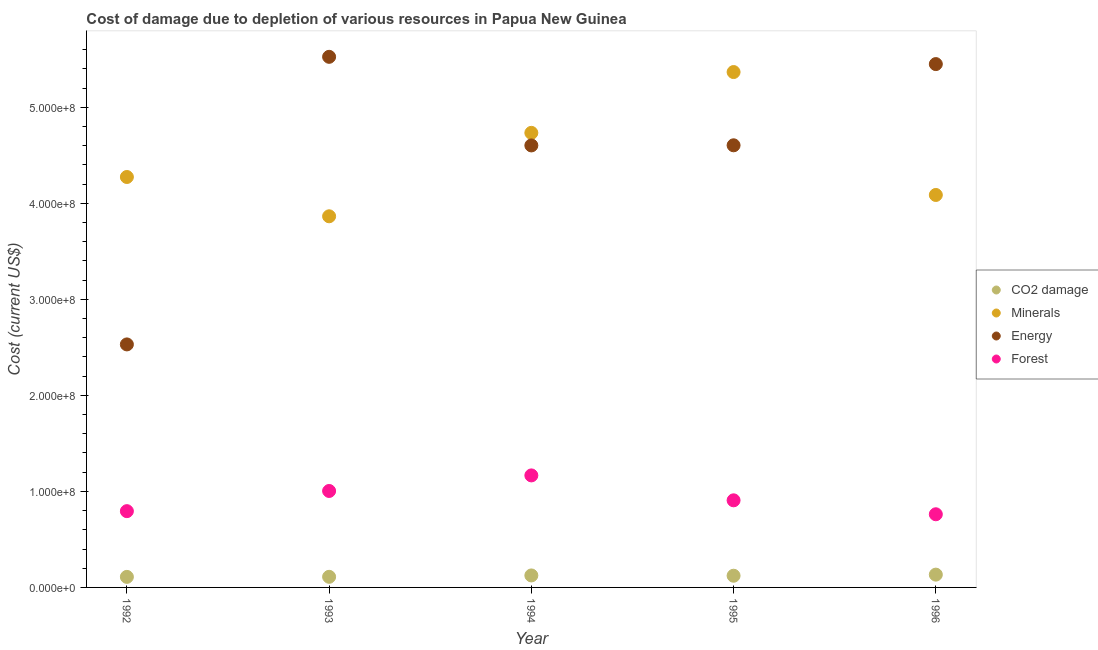What is the cost of damage due to depletion of coal in 1996?
Your response must be concise. 1.33e+07. Across all years, what is the maximum cost of damage due to depletion of energy?
Your response must be concise. 5.53e+08. Across all years, what is the minimum cost of damage due to depletion of minerals?
Offer a very short reply. 3.86e+08. What is the total cost of damage due to depletion of coal in the graph?
Your response must be concise. 6.00e+07. What is the difference between the cost of damage due to depletion of energy in 1995 and that in 1996?
Make the answer very short. -8.46e+07. What is the difference between the cost of damage due to depletion of energy in 1994 and the cost of damage due to depletion of forests in 1995?
Offer a terse response. 3.70e+08. What is the average cost of damage due to depletion of energy per year?
Your response must be concise. 4.54e+08. In the year 1992, what is the difference between the cost of damage due to depletion of energy and cost of damage due to depletion of minerals?
Your response must be concise. -1.74e+08. In how many years, is the cost of damage due to depletion of coal greater than 520000000 US$?
Make the answer very short. 0. What is the ratio of the cost of damage due to depletion of forests in 1992 to that in 1996?
Offer a terse response. 1.04. Is the difference between the cost of damage due to depletion of coal in 1993 and 1995 greater than the difference between the cost of damage due to depletion of minerals in 1993 and 1995?
Offer a terse response. Yes. What is the difference between the highest and the second highest cost of damage due to depletion of forests?
Give a very brief answer. 1.62e+07. What is the difference between the highest and the lowest cost of damage due to depletion of minerals?
Keep it short and to the point. 1.50e+08. In how many years, is the cost of damage due to depletion of energy greater than the average cost of damage due to depletion of energy taken over all years?
Keep it short and to the point. 4. Is it the case that in every year, the sum of the cost of damage due to depletion of forests and cost of damage due to depletion of minerals is greater than the sum of cost of damage due to depletion of coal and cost of damage due to depletion of energy?
Your response must be concise. No. Does the cost of damage due to depletion of energy monotonically increase over the years?
Provide a short and direct response. No. How many dotlines are there?
Provide a succinct answer. 4. What is the difference between two consecutive major ticks on the Y-axis?
Ensure brevity in your answer.  1.00e+08. Are the values on the major ticks of Y-axis written in scientific E-notation?
Make the answer very short. Yes. Does the graph contain grids?
Keep it short and to the point. No. Where does the legend appear in the graph?
Provide a short and direct response. Center right. How many legend labels are there?
Offer a terse response. 4. How are the legend labels stacked?
Provide a short and direct response. Vertical. What is the title of the graph?
Offer a terse response. Cost of damage due to depletion of various resources in Papua New Guinea . What is the label or title of the X-axis?
Your answer should be very brief. Year. What is the label or title of the Y-axis?
Ensure brevity in your answer.  Cost (current US$). What is the Cost (current US$) of CO2 damage in 1992?
Your answer should be compact. 1.10e+07. What is the Cost (current US$) of Minerals in 1992?
Offer a terse response. 4.27e+08. What is the Cost (current US$) in Energy in 1992?
Offer a very short reply. 2.53e+08. What is the Cost (current US$) in Forest in 1992?
Give a very brief answer. 7.94e+07. What is the Cost (current US$) in CO2 damage in 1993?
Offer a terse response. 1.10e+07. What is the Cost (current US$) in Minerals in 1993?
Offer a terse response. 3.86e+08. What is the Cost (current US$) in Energy in 1993?
Offer a terse response. 5.53e+08. What is the Cost (current US$) of Forest in 1993?
Keep it short and to the point. 1.00e+08. What is the Cost (current US$) of CO2 damage in 1994?
Offer a very short reply. 1.25e+07. What is the Cost (current US$) in Minerals in 1994?
Your answer should be compact. 4.73e+08. What is the Cost (current US$) in Energy in 1994?
Ensure brevity in your answer.  4.60e+08. What is the Cost (current US$) of Forest in 1994?
Make the answer very short. 1.17e+08. What is the Cost (current US$) of CO2 damage in 1995?
Ensure brevity in your answer.  1.22e+07. What is the Cost (current US$) of Minerals in 1995?
Give a very brief answer. 5.37e+08. What is the Cost (current US$) of Energy in 1995?
Provide a short and direct response. 4.60e+08. What is the Cost (current US$) of Forest in 1995?
Provide a short and direct response. 9.07e+07. What is the Cost (current US$) in CO2 damage in 1996?
Keep it short and to the point. 1.33e+07. What is the Cost (current US$) of Minerals in 1996?
Offer a terse response. 4.09e+08. What is the Cost (current US$) in Energy in 1996?
Make the answer very short. 5.45e+08. What is the Cost (current US$) of Forest in 1996?
Provide a succinct answer. 7.62e+07. Across all years, what is the maximum Cost (current US$) in CO2 damage?
Your answer should be very brief. 1.33e+07. Across all years, what is the maximum Cost (current US$) of Minerals?
Your answer should be very brief. 5.37e+08. Across all years, what is the maximum Cost (current US$) in Energy?
Your answer should be very brief. 5.53e+08. Across all years, what is the maximum Cost (current US$) of Forest?
Your response must be concise. 1.17e+08. Across all years, what is the minimum Cost (current US$) in CO2 damage?
Your answer should be very brief. 1.10e+07. Across all years, what is the minimum Cost (current US$) of Minerals?
Your answer should be compact. 3.86e+08. Across all years, what is the minimum Cost (current US$) of Energy?
Provide a succinct answer. 2.53e+08. Across all years, what is the minimum Cost (current US$) in Forest?
Give a very brief answer. 7.62e+07. What is the total Cost (current US$) in CO2 damage in the graph?
Offer a very short reply. 6.00e+07. What is the total Cost (current US$) of Minerals in the graph?
Your answer should be compact. 2.23e+09. What is the total Cost (current US$) of Energy in the graph?
Provide a short and direct response. 2.27e+09. What is the total Cost (current US$) of Forest in the graph?
Provide a short and direct response. 4.63e+08. What is the difference between the Cost (current US$) of CO2 damage in 1992 and that in 1993?
Your answer should be compact. -6.84e+04. What is the difference between the Cost (current US$) of Minerals in 1992 and that in 1993?
Ensure brevity in your answer.  4.09e+07. What is the difference between the Cost (current US$) in Energy in 1992 and that in 1993?
Keep it short and to the point. -2.99e+08. What is the difference between the Cost (current US$) in Forest in 1992 and that in 1993?
Give a very brief answer. -2.10e+07. What is the difference between the Cost (current US$) in CO2 damage in 1992 and that in 1994?
Your answer should be compact. -1.51e+06. What is the difference between the Cost (current US$) in Minerals in 1992 and that in 1994?
Offer a very short reply. -4.60e+07. What is the difference between the Cost (current US$) in Energy in 1992 and that in 1994?
Ensure brevity in your answer.  -2.07e+08. What is the difference between the Cost (current US$) of Forest in 1992 and that in 1994?
Your answer should be very brief. -3.72e+07. What is the difference between the Cost (current US$) of CO2 damage in 1992 and that in 1995?
Your answer should be very brief. -1.20e+06. What is the difference between the Cost (current US$) in Minerals in 1992 and that in 1995?
Make the answer very short. -1.09e+08. What is the difference between the Cost (current US$) of Energy in 1992 and that in 1995?
Your answer should be compact. -2.07e+08. What is the difference between the Cost (current US$) in Forest in 1992 and that in 1995?
Offer a very short reply. -1.13e+07. What is the difference between the Cost (current US$) of CO2 damage in 1992 and that in 1996?
Provide a succinct answer. -2.35e+06. What is the difference between the Cost (current US$) in Minerals in 1992 and that in 1996?
Provide a succinct answer. 1.87e+07. What is the difference between the Cost (current US$) in Energy in 1992 and that in 1996?
Ensure brevity in your answer.  -2.92e+08. What is the difference between the Cost (current US$) in Forest in 1992 and that in 1996?
Your answer should be compact. 3.24e+06. What is the difference between the Cost (current US$) in CO2 damage in 1993 and that in 1994?
Keep it short and to the point. -1.44e+06. What is the difference between the Cost (current US$) of Minerals in 1993 and that in 1994?
Your answer should be very brief. -8.69e+07. What is the difference between the Cost (current US$) of Energy in 1993 and that in 1994?
Give a very brief answer. 9.23e+07. What is the difference between the Cost (current US$) in Forest in 1993 and that in 1994?
Offer a terse response. -1.62e+07. What is the difference between the Cost (current US$) in CO2 damage in 1993 and that in 1995?
Offer a very short reply. -1.13e+06. What is the difference between the Cost (current US$) in Minerals in 1993 and that in 1995?
Ensure brevity in your answer.  -1.50e+08. What is the difference between the Cost (current US$) in Energy in 1993 and that in 1995?
Make the answer very short. 9.21e+07. What is the difference between the Cost (current US$) in Forest in 1993 and that in 1995?
Keep it short and to the point. 9.73e+06. What is the difference between the Cost (current US$) of CO2 damage in 1993 and that in 1996?
Offer a terse response. -2.28e+06. What is the difference between the Cost (current US$) in Minerals in 1993 and that in 1996?
Offer a terse response. -2.22e+07. What is the difference between the Cost (current US$) in Energy in 1993 and that in 1996?
Your answer should be compact. 7.56e+06. What is the difference between the Cost (current US$) of Forest in 1993 and that in 1996?
Provide a succinct answer. 2.43e+07. What is the difference between the Cost (current US$) in CO2 damage in 1994 and that in 1995?
Your answer should be compact. 3.05e+05. What is the difference between the Cost (current US$) of Minerals in 1994 and that in 1995?
Give a very brief answer. -6.33e+07. What is the difference between the Cost (current US$) in Energy in 1994 and that in 1995?
Offer a terse response. -1.42e+05. What is the difference between the Cost (current US$) of Forest in 1994 and that in 1995?
Offer a terse response. 2.59e+07. What is the difference between the Cost (current US$) in CO2 damage in 1994 and that in 1996?
Your response must be concise. -8.44e+05. What is the difference between the Cost (current US$) of Minerals in 1994 and that in 1996?
Offer a terse response. 6.47e+07. What is the difference between the Cost (current US$) in Energy in 1994 and that in 1996?
Provide a succinct answer. -8.47e+07. What is the difference between the Cost (current US$) of Forest in 1994 and that in 1996?
Offer a terse response. 4.05e+07. What is the difference between the Cost (current US$) in CO2 damage in 1995 and that in 1996?
Your answer should be compact. -1.15e+06. What is the difference between the Cost (current US$) in Minerals in 1995 and that in 1996?
Offer a very short reply. 1.28e+08. What is the difference between the Cost (current US$) in Energy in 1995 and that in 1996?
Your response must be concise. -8.46e+07. What is the difference between the Cost (current US$) of Forest in 1995 and that in 1996?
Make the answer very short. 1.45e+07. What is the difference between the Cost (current US$) in CO2 damage in 1992 and the Cost (current US$) in Minerals in 1993?
Offer a very short reply. -3.75e+08. What is the difference between the Cost (current US$) of CO2 damage in 1992 and the Cost (current US$) of Energy in 1993?
Offer a very short reply. -5.42e+08. What is the difference between the Cost (current US$) of CO2 damage in 1992 and the Cost (current US$) of Forest in 1993?
Provide a succinct answer. -8.95e+07. What is the difference between the Cost (current US$) in Minerals in 1992 and the Cost (current US$) in Energy in 1993?
Your response must be concise. -1.25e+08. What is the difference between the Cost (current US$) of Minerals in 1992 and the Cost (current US$) of Forest in 1993?
Your answer should be very brief. 3.27e+08. What is the difference between the Cost (current US$) in Energy in 1992 and the Cost (current US$) in Forest in 1993?
Ensure brevity in your answer.  1.53e+08. What is the difference between the Cost (current US$) of CO2 damage in 1992 and the Cost (current US$) of Minerals in 1994?
Offer a terse response. -4.62e+08. What is the difference between the Cost (current US$) of CO2 damage in 1992 and the Cost (current US$) of Energy in 1994?
Your answer should be compact. -4.49e+08. What is the difference between the Cost (current US$) in CO2 damage in 1992 and the Cost (current US$) in Forest in 1994?
Ensure brevity in your answer.  -1.06e+08. What is the difference between the Cost (current US$) in Minerals in 1992 and the Cost (current US$) in Energy in 1994?
Keep it short and to the point. -3.29e+07. What is the difference between the Cost (current US$) in Minerals in 1992 and the Cost (current US$) in Forest in 1994?
Provide a short and direct response. 3.11e+08. What is the difference between the Cost (current US$) of Energy in 1992 and the Cost (current US$) of Forest in 1994?
Make the answer very short. 1.36e+08. What is the difference between the Cost (current US$) of CO2 damage in 1992 and the Cost (current US$) of Minerals in 1995?
Make the answer very short. -5.26e+08. What is the difference between the Cost (current US$) in CO2 damage in 1992 and the Cost (current US$) in Energy in 1995?
Offer a terse response. -4.49e+08. What is the difference between the Cost (current US$) of CO2 damage in 1992 and the Cost (current US$) of Forest in 1995?
Your answer should be very brief. -7.97e+07. What is the difference between the Cost (current US$) of Minerals in 1992 and the Cost (current US$) of Energy in 1995?
Your response must be concise. -3.30e+07. What is the difference between the Cost (current US$) of Minerals in 1992 and the Cost (current US$) of Forest in 1995?
Your response must be concise. 3.37e+08. What is the difference between the Cost (current US$) in Energy in 1992 and the Cost (current US$) in Forest in 1995?
Keep it short and to the point. 1.62e+08. What is the difference between the Cost (current US$) of CO2 damage in 1992 and the Cost (current US$) of Minerals in 1996?
Provide a short and direct response. -3.98e+08. What is the difference between the Cost (current US$) of CO2 damage in 1992 and the Cost (current US$) of Energy in 1996?
Ensure brevity in your answer.  -5.34e+08. What is the difference between the Cost (current US$) of CO2 damage in 1992 and the Cost (current US$) of Forest in 1996?
Your response must be concise. -6.52e+07. What is the difference between the Cost (current US$) in Minerals in 1992 and the Cost (current US$) in Energy in 1996?
Your answer should be very brief. -1.18e+08. What is the difference between the Cost (current US$) in Minerals in 1992 and the Cost (current US$) in Forest in 1996?
Offer a terse response. 3.51e+08. What is the difference between the Cost (current US$) of Energy in 1992 and the Cost (current US$) of Forest in 1996?
Provide a short and direct response. 1.77e+08. What is the difference between the Cost (current US$) of CO2 damage in 1993 and the Cost (current US$) of Minerals in 1994?
Ensure brevity in your answer.  -4.62e+08. What is the difference between the Cost (current US$) in CO2 damage in 1993 and the Cost (current US$) in Energy in 1994?
Offer a very short reply. -4.49e+08. What is the difference between the Cost (current US$) in CO2 damage in 1993 and the Cost (current US$) in Forest in 1994?
Offer a very short reply. -1.06e+08. What is the difference between the Cost (current US$) in Minerals in 1993 and the Cost (current US$) in Energy in 1994?
Provide a succinct answer. -7.38e+07. What is the difference between the Cost (current US$) in Minerals in 1993 and the Cost (current US$) in Forest in 1994?
Your answer should be compact. 2.70e+08. What is the difference between the Cost (current US$) in Energy in 1993 and the Cost (current US$) in Forest in 1994?
Your answer should be very brief. 4.36e+08. What is the difference between the Cost (current US$) of CO2 damage in 1993 and the Cost (current US$) of Minerals in 1995?
Offer a very short reply. -5.26e+08. What is the difference between the Cost (current US$) in CO2 damage in 1993 and the Cost (current US$) in Energy in 1995?
Provide a short and direct response. -4.49e+08. What is the difference between the Cost (current US$) in CO2 damage in 1993 and the Cost (current US$) in Forest in 1995?
Keep it short and to the point. -7.97e+07. What is the difference between the Cost (current US$) in Minerals in 1993 and the Cost (current US$) in Energy in 1995?
Offer a very short reply. -7.39e+07. What is the difference between the Cost (current US$) of Minerals in 1993 and the Cost (current US$) of Forest in 1995?
Your answer should be compact. 2.96e+08. What is the difference between the Cost (current US$) in Energy in 1993 and the Cost (current US$) in Forest in 1995?
Ensure brevity in your answer.  4.62e+08. What is the difference between the Cost (current US$) of CO2 damage in 1993 and the Cost (current US$) of Minerals in 1996?
Ensure brevity in your answer.  -3.98e+08. What is the difference between the Cost (current US$) in CO2 damage in 1993 and the Cost (current US$) in Energy in 1996?
Your response must be concise. -5.34e+08. What is the difference between the Cost (current US$) of CO2 damage in 1993 and the Cost (current US$) of Forest in 1996?
Your answer should be very brief. -6.51e+07. What is the difference between the Cost (current US$) of Minerals in 1993 and the Cost (current US$) of Energy in 1996?
Make the answer very short. -1.58e+08. What is the difference between the Cost (current US$) in Minerals in 1993 and the Cost (current US$) in Forest in 1996?
Offer a terse response. 3.10e+08. What is the difference between the Cost (current US$) in Energy in 1993 and the Cost (current US$) in Forest in 1996?
Offer a very short reply. 4.76e+08. What is the difference between the Cost (current US$) of CO2 damage in 1994 and the Cost (current US$) of Minerals in 1995?
Provide a succinct answer. -5.24e+08. What is the difference between the Cost (current US$) in CO2 damage in 1994 and the Cost (current US$) in Energy in 1995?
Your answer should be very brief. -4.48e+08. What is the difference between the Cost (current US$) of CO2 damage in 1994 and the Cost (current US$) of Forest in 1995?
Your answer should be compact. -7.82e+07. What is the difference between the Cost (current US$) in Minerals in 1994 and the Cost (current US$) in Energy in 1995?
Your answer should be compact. 1.30e+07. What is the difference between the Cost (current US$) in Minerals in 1994 and the Cost (current US$) in Forest in 1995?
Keep it short and to the point. 3.83e+08. What is the difference between the Cost (current US$) in Energy in 1994 and the Cost (current US$) in Forest in 1995?
Make the answer very short. 3.70e+08. What is the difference between the Cost (current US$) in CO2 damage in 1994 and the Cost (current US$) in Minerals in 1996?
Offer a terse response. -3.96e+08. What is the difference between the Cost (current US$) in CO2 damage in 1994 and the Cost (current US$) in Energy in 1996?
Provide a short and direct response. -5.32e+08. What is the difference between the Cost (current US$) in CO2 damage in 1994 and the Cost (current US$) in Forest in 1996?
Give a very brief answer. -6.37e+07. What is the difference between the Cost (current US$) of Minerals in 1994 and the Cost (current US$) of Energy in 1996?
Your answer should be very brief. -7.16e+07. What is the difference between the Cost (current US$) in Minerals in 1994 and the Cost (current US$) in Forest in 1996?
Make the answer very short. 3.97e+08. What is the difference between the Cost (current US$) in Energy in 1994 and the Cost (current US$) in Forest in 1996?
Keep it short and to the point. 3.84e+08. What is the difference between the Cost (current US$) in CO2 damage in 1995 and the Cost (current US$) in Minerals in 1996?
Provide a short and direct response. -3.96e+08. What is the difference between the Cost (current US$) in CO2 damage in 1995 and the Cost (current US$) in Energy in 1996?
Offer a very short reply. -5.33e+08. What is the difference between the Cost (current US$) of CO2 damage in 1995 and the Cost (current US$) of Forest in 1996?
Offer a terse response. -6.40e+07. What is the difference between the Cost (current US$) of Minerals in 1995 and the Cost (current US$) of Energy in 1996?
Your response must be concise. -8.29e+06. What is the difference between the Cost (current US$) in Minerals in 1995 and the Cost (current US$) in Forest in 1996?
Give a very brief answer. 4.60e+08. What is the difference between the Cost (current US$) in Energy in 1995 and the Cost (current US$) in Forest in 1996?
Provide a succinct answer. 3.84e+08. What is the average Cost (current US$) in CO2 damage per year?
Keep it short and to the point. 1.20e+07. What is the average Cost (current US$) of Minerals per year?
Offer a terse response. 4.47e+08. What is the average Cost (current US$) in Energy per year?
Keep it short and to the point. 4.54e+08. What is the average Cost (current US$) in Forest per year?
Provide a succinct answer. 9.27e+07. In the year 1992, what is the difference between the Cost (current US$) of CO2 damage and Cost (current US$) of Minerals?
Your response must be concise. -4.16e+08. In the year 1992, what is the difference between the Cost (current US$) of CO2 damage and Cost (current US$) of Energy?
Your answer should be compact. -2.42e+08. In the year 1992, what is the difference between the Cost (current US$) of CO2 damage and Cost (current US$) of Forest?
Offer a terse response. -6.84e+07. In the year 1992, what is the difference between the Cost (current US$) in Minerals and Cost (current US$) in Energy?
Make the answer very short. 1.74e+08. In the year 1992, what is the difference between the Cost (current US$) in Minerals and Cost (current US$) in Forest?
Give a very brief answer. 3.48e+08. In the year 1992, what is the difference between the Cost (current US$) of Energy and Cost (current US$) of Forest?
Your answer should be very brief. 1.74e+08. In the year 1993, what is the difference between the Cost (current US$) of CO2 damage and Cost (current US$) of Minerals?
Give a very brief answer. -3.75e+08. In the year 1993, what is the difference between the Cost (current US$) in CO2 damage and Cost (current US$) in Energy?
Offer a very short reply. -5.41e+08. In the year 1993, what is the difference between the Cost (current US$) of CO2 damage and Cost (current US$) of Forest?
Your response must be concise. -8.94e+07. In the year 1993, what is the difference between the Cost (current US$) in Minerals and Cost (current US$) in Energy?
Your response must be concise. -1.66e+08. In the year 1993, what is the difference between the Cost (current US$) of Minerals and Cost (current US$) of Forest?
Your response must be concise. 2.86e+08. In the year 1993, what is the difference between the Cost (current US$) in Energy and Cost (current US$) in Forest?
Ensure brevity in your answer.  4.52e+08. In the year 1994, what is the difference between the Cost (current US$) in CO2 damage and Cost (current US$) in Minerals?
Provide a short and direct response. -4.61e+08. In the year 1994, what is the difference between the Cost (current US$) in CO2 damage and Cost (current US$) in Energy?
Give a very brief answer. -4.48e+08. In the year 1994, what is the difference between the Cost (current US$) of CO2 damage and Cost (current US$) of Forest?
Provide a succinct answer. -1.04e+08. In the year 1994, what is the difference between the Cost (current US$) of Minerals and Cost (current US$) of Energy?
Provide a succinct answer. 1.31e+07. In the year 1994, what is the difference between the Cost (current US$) in Minerals and Cost (current US$) in Forest?
Your answer should be very brief. 3.57e+08. In the year 1994, what is the difference between the Cost (current US$) in Energy and Cost (current US$) in Forest?
Offer a terse response. 3.44e+08. In the year 1995, what is the difference between the Cost (current US$) in CO2 damage and Cost (current US$) in Minerals?
Give a very brief answer. -5.24e+08. In the year 1995, what is the difference between the Cost (current US$) in CO2 damage and Cost (current US$) in Energy?
Offer a very short reply. -4.48e+08. In the year 1995, what is the difference between the Cost (current US$) in CO2 damage and Cost (current US$) in Forest?
Your response must be concise. -7.85e+07. In the year 1995, what is the difference between the Cost (current US$) of Minerals and Cost (current US$) of Energy?
Offer a very short reply. 7.63e+07. In the year 1995, what is the difference between the Cost (current US$) of Minerals and Cost (current US$) of Forest?
Your answer should be compact. 4.46e+08. In the year 1995, what is the difference between the Cost (current US$) in Energy and Cost (current US$) in Forest?
Your answer should be very brief. 3.70e+08. In the year 1996, what is the difference between the Cost (current US$) in CO2 damage and Cost (current US$) in Minerals?
Keep it short and to the point. -3.95e+08. In the year 1996, what is the difference between the Cost (current US$) of CO2 damage and Cost (current US$) of Energy?
Provide a succinct answer. -5.32e+08. In the year 1996, what is the difference between the Cost (current US$) of CO2 damage and Cost (current US$) of Forest?
Make the answer very short. -6.29e+07. In the year 1996, what is the difference between the Cost (current US$) of Minerals and Cost (current US$) of Energy?
Provide a short and direct response. -1.36e+08. In the year 1996, what is the difference between the Cost (current US$) of Minerals and Cost (current US$) of Forest?
Provide a succinct answer. 3.32e+08. In the year 1996, what is the difference between the Cost (current US$) in Energy and Cost (current US$) in Forest?
Make the answer very short. 4.69e+08. What is the ratio of the Cost (current US$) in Minerals in 1992 to that in 1993?
Offer a terse response. 1.11. What is the ratio of the Cost (current US$) of Energy in 1992 to that in 1993?
Your answer should be very brief. 0.46. What is the ratio of the Cost (current US$) in Forest in 1992 to that in 1993?
Your answer should be very brief. 0.79. What is the ratio of the Cost (current US$) in CO2 damage in 1992 to that in 1994?
Your response must be concise. 0.88. What is the ratio of the Cost (current US$) in Minerals in 1992 to that in 1994?
Provide a short and direct response. 0.9. What is the ratio of the Cost (current US$) of Energy in 1992 to that in 1994?
Provide a short and direct response. 0.55. What is the ratio of the Cost (current US$) in Forest in 1992 to that in 1994?
Give a very brief answer. 0.68. What is the ratio of the Cost (current US$) of CO2 damage in 1992 to that in 1995?
Offer a terse response. 0.9. What is the ratio of the Cost (current US$) of Minerals in 1992 to that in 1995?
Give a very brief answer. 0.8. What is the ratio of the Cost (current US$) of Energy in 1992 to that in 1995?
Your response must be concise. 0.55. What is the ratio of the Cost (current US$) of Forest in 1992 to that in 1995?
Give a very brief answer. 0.88. What is the ratio of the Cost (current US$) in CO2 damage in 1992 to that in 1996?
Give a very brief answer. 0.82. What is the ratio of the Cost (current US$) in Minerals in 1992 to that in 1996?
Offer a terse response. 1.05. What is the ratio of the Cost (current US$) in Energy in 1992 to that in 1996?
Your answer should be very brief. 0.46. What is the ratio of the Cost (current US$) in Forest in 1992 to that in 1996?
Offer a terse response. 1.04. What is the ratio of the Cost (current US$) in CO2 damage in 1993 to that in 1994?
Ensure brevity in your answer.  0.88. What is the ratio of the Cost (current US$) of Minerals in 1993 to that in 1994?
Provide a short and direct response. 0.82. What is the ratio of the Cost (current US$) of Energy in 1993 to that in 1994?
Give a very brief answer. 1.2. What is the ratio of the Cost (current US$) of Forest in 1993 to that in 1994?
Offer a very short reply. 0.86. What is the ratio of the Cost (current US$) of CO2 damage in 1993 to that in 1995?
Offer a very short reply. 0.91. What is the ratio of the Cost (current US$) in Minerals in 1993 to that in 1995?
Keep it short and to the point. 0.72. What is the ratio of the Cost (current US$) in Energy in 1993 to that in 1995?
Your answer should be compact. 1.2. What is the ratio of the Cost (current US$) of Forest in 1993 to that in 1995?
Your answer should be very brief. 1.11. What is the ratio of the Cost (current US$) in CO2 damage in 1993 to that in 1996?
Make the answer very short. 0.83. What is the ratio of the Cost (current US$) of Minerals in 1993 to that in 1996?
Your response must be concise. 0.95. What is the ratio of the Cost (current US$) in Energy in 1993 to that in 1996?
Your answer should be compact. 1.01. What is the ratio of the Cost (current US$) in Forest in 1993 to that in 1996?
Provide a succinct answer. 1.32. What is the ratio of the Cost (current US$) of CO2 damage in 1994 to that in 1995?
Offer a terse response. 1.02. What is the ratio of the Cost (current US$) of Minerals in 1994 to that in 1995?
Provide a short and direct response. 0.88. What is the ratio of the Cost (current US$) of Forest in 1994 to that in 1995?
Give a very brief answer. 1.29. What is the ratio of the Cost (current US$) of CO2 damage in 1994 to that in 1996?
Provide a short and direct response. 0.94. What is the ratio of the Cost (current US$) of Minerals in 1994 to that in 1996?
Keep it short and to the point. 1.16. What is the ratio of the Cost (current US$) in Energy in 1994 to that in 1996?
Your response must be concise. 0.84. What is the ratio of the Cost (current US$) in Forest in 1994 to that in 1996?
Give a very brief answer. 1.53. What is the ratio of the Cost (current US$) of CO2 damage in 1995 to that in 1996?
Provide a short and direct response. 0.91. What is the ratio of the Cost (current US$) of Minerals in 1995 to that in 1996?
Your response must be concise. 1.31. What is the ratio of the Cost (current US$) in Energy in 1995 to that in 1996?
Keep it short and to the point. 0.84. What is the ratio of the Cost (current US$) of Forest in 1995 to that in 1996?
Your response must be concise. 1.19. What is the difference between the highest and the second highest Cost (current US$) in CO2 damage?
Provide a short and direct response. 8.44e+05. What is the difference between the highest and the second highest Cost (current US$) of Minerals?
Give a very brief answer. 6.33e+07. What is the difference between the highest and the second highest Cost (current US$) of Energy?
Keep it short and to the point. 7.56e+06. What is the difference between the highest and the second highest Cost (current US$) in Forest?
Your answer should be very brief. 1.62e+07. What is the difference between the highest and the lowest Cost (current US$) of CO2 damage?
Keep it short and to the point. 2.35e+06. What is the difference between the highest and the lowest Cost (current US$) of Minerals?
Offer a very short reply. 1.50e+08. What is the difference between the highest and the lowest Cost (current US$) of Energy?
Make the answer very short. 2.99e+08. What is the difference between the highest and the lowest Cost (current US$) of Forest?
Your answer should be very brief. 4.05e+07. 